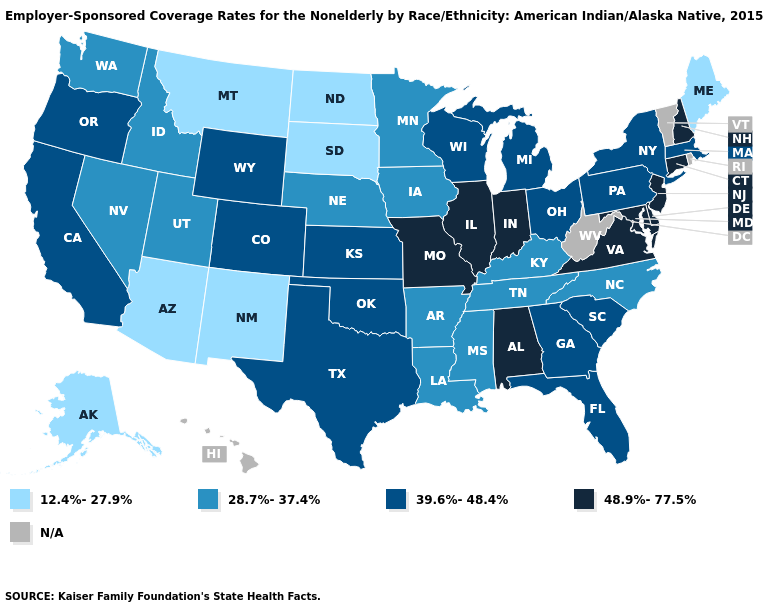Name the states that have a value in the range 48.9%-77.5%?
Quick response, please. Alabama, Connecticut, Delaware, Illinois, Indiana, Maryland, Missouri, New Hampshire, New Jersey, Virginia. Does California have the lowest value in the West?
Answer briefly. No. What is the value of New Hampshire?
Concise answer only. 48.9%-77.5%. Which states have the lowest value in the West?
Short answer required. Alaska, Arizona, Montana, New Mexico. Name the states that have a value in the range 28.7%-37.4%?
Be succinct. Arkansas, Idaho, Iowa, Kentucky, Louisiana, Minnesota, Mississippi, Nebraska, Nevada, North Carolina, Tennessee, Utah, Washington. What is the value of Tennessee?
Keep it brief. 28.7%-37.4%. What is the lowest value in the South?
Write a very short answer. 28.7%-37.4%. What is the value of Illinois?
Keep it brief. 48.9%-77.5%. Does the first symbol in the legend represent the smallest category?
Concise answer only. Yes. Among the states that border South Dakota , which have the highest value?
Answer briefly. Wyoming. What is the value of New Jersey?
Answer briefly. 48.9%-77.5%. Which states have the lowest value in the USA?
Quick response, please. Alaska, Arizona, Maine, Montana, New Mexico, North Dakota, South Dakota. What is the value of Ohio?
Be succinct. 39.6%-48.4%. 